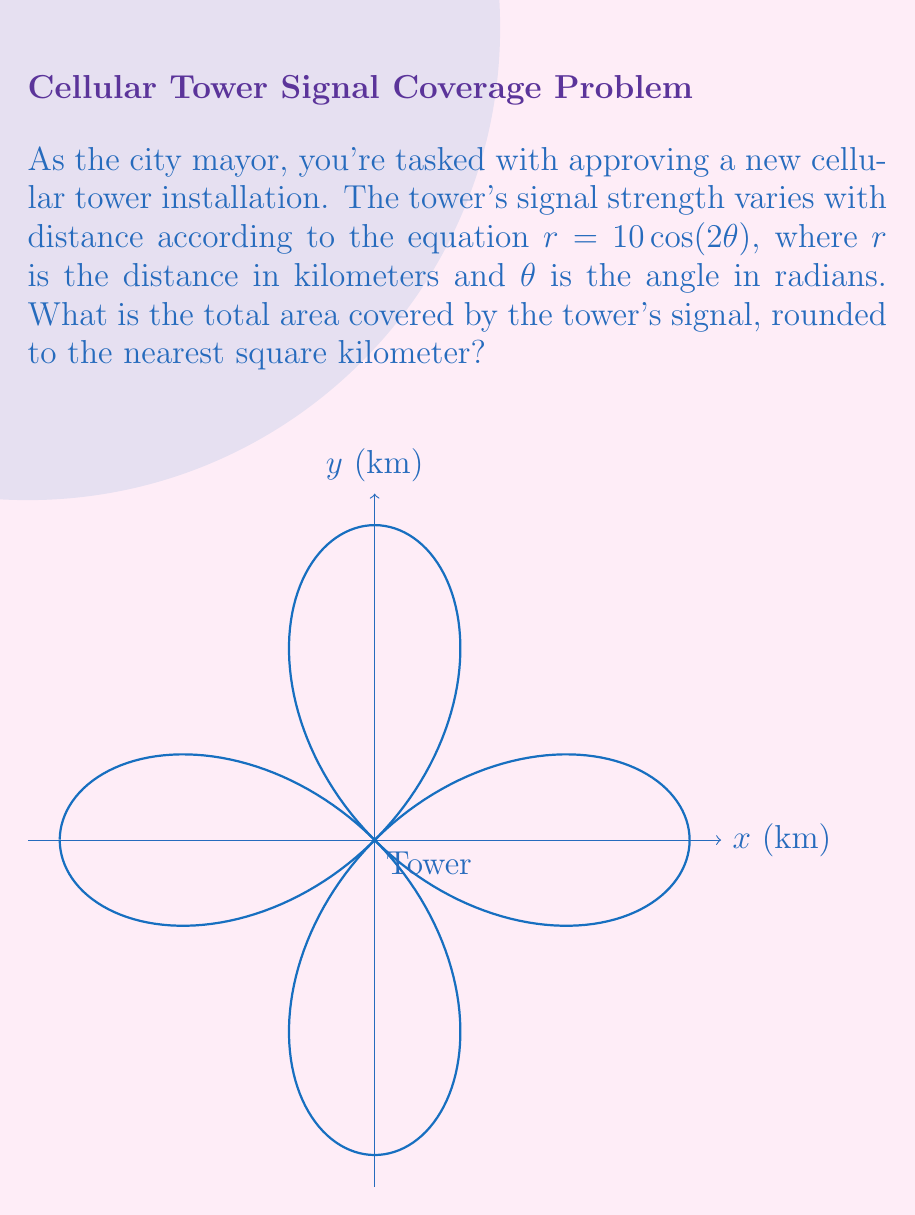Can you answer this question? To solve this problem, we need to follow these steps:

1) The area of a polar curve is given by the formula:

   $$A = \frac{1}{2}\int_0^{2\pi} r^2(\theta) d\theta$$

2) In our case, $r(\theta) = 10\cos(2\theta)$. We need to square this:

   $$r^2(\theta) = 100\cos^2(2\theta)$$

3) Now we can set up our integral:

   $$A = \frac{1}{2}\int_0^{2\pi} 100\cos^2(2\theta) d\theta$$

4) This can be simplified to:

   $$A = 50\int_0^{2\pi} \cos^2(2\theta) d\theta$$

5) We can use the trigonometric identity $\cos^2(x) = \frac{1 + \cos(2x)}{2}$:

   $$A = 50\int_0^{2\pi} \frac{1 + \cos(4\theta)}{2} d\theta$$

6) Simplifying:

   $$A = 25\int_0^{2\pi} (1 + \cos(4\theta)) d\theta$$

7) Integrating:

   $$A = 25[\theta + \frac{1}{4}\sin(4\theta)]_0^{2\pi}$$

8) Evaluating:

   $$A = 25[2\pi + 0 - (0 + 0)] = 50\pi$$

9) Therefore, the area is $50\pi$ square kilometers.

10) Rounding to the nearest square kilometer:

    $50\pi \approx 157$ square kilometers
Answer: 157 km² 